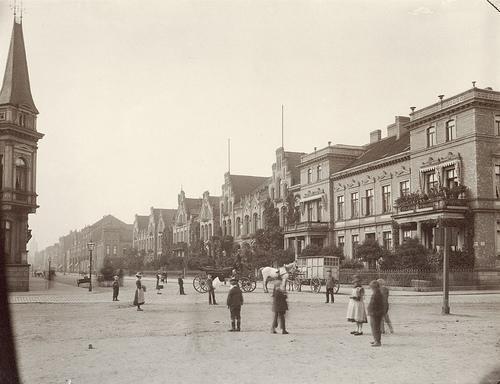How many horses are in this picture?
Give a very brief answer. 1. How many people are in the foreground?
Give a very brief answer. 5. How many lampposts do you see?
Give a very brief answer. 3. How many elephants are behind the fence?
Give a very brief answer. 0. 